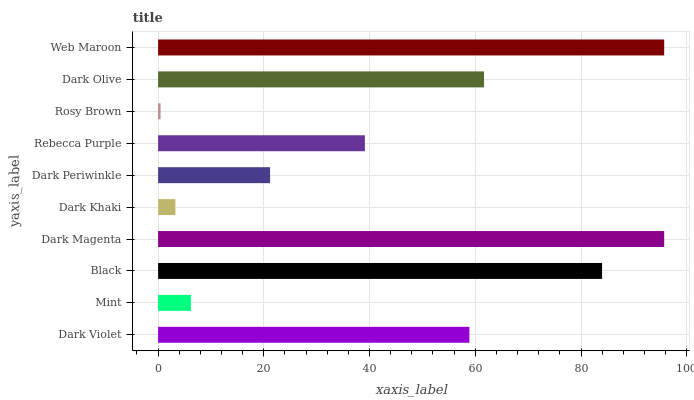Is Rosy Brown the minimum?
Answer yes or no. Yes. Is Web Maroon the maximum?
Answer yes or no. Yes. Is Mint the minimum?
Answer yes or no. No. Is Mint the maximum?
Answer yes or no. No. Is Dark Violet greater than Mint?
Answer yes or no. Yes. Is Mint less than Dark Violet?
Answer yes or no. Yes. Is Mint greater than Dark Violet?
Answer yes or no. No. Is Dark Violet less than Mint?
Answer yes or no. No. Is Dark Violet the high median?
Answer yes or no. Yes. Is Rebecca Purple the low median?
Answer yes or no. Yes. Is Mint the high median?
Answer yes or no. No. Is Dark Khaki the low median?
Answer yes or no. No. 